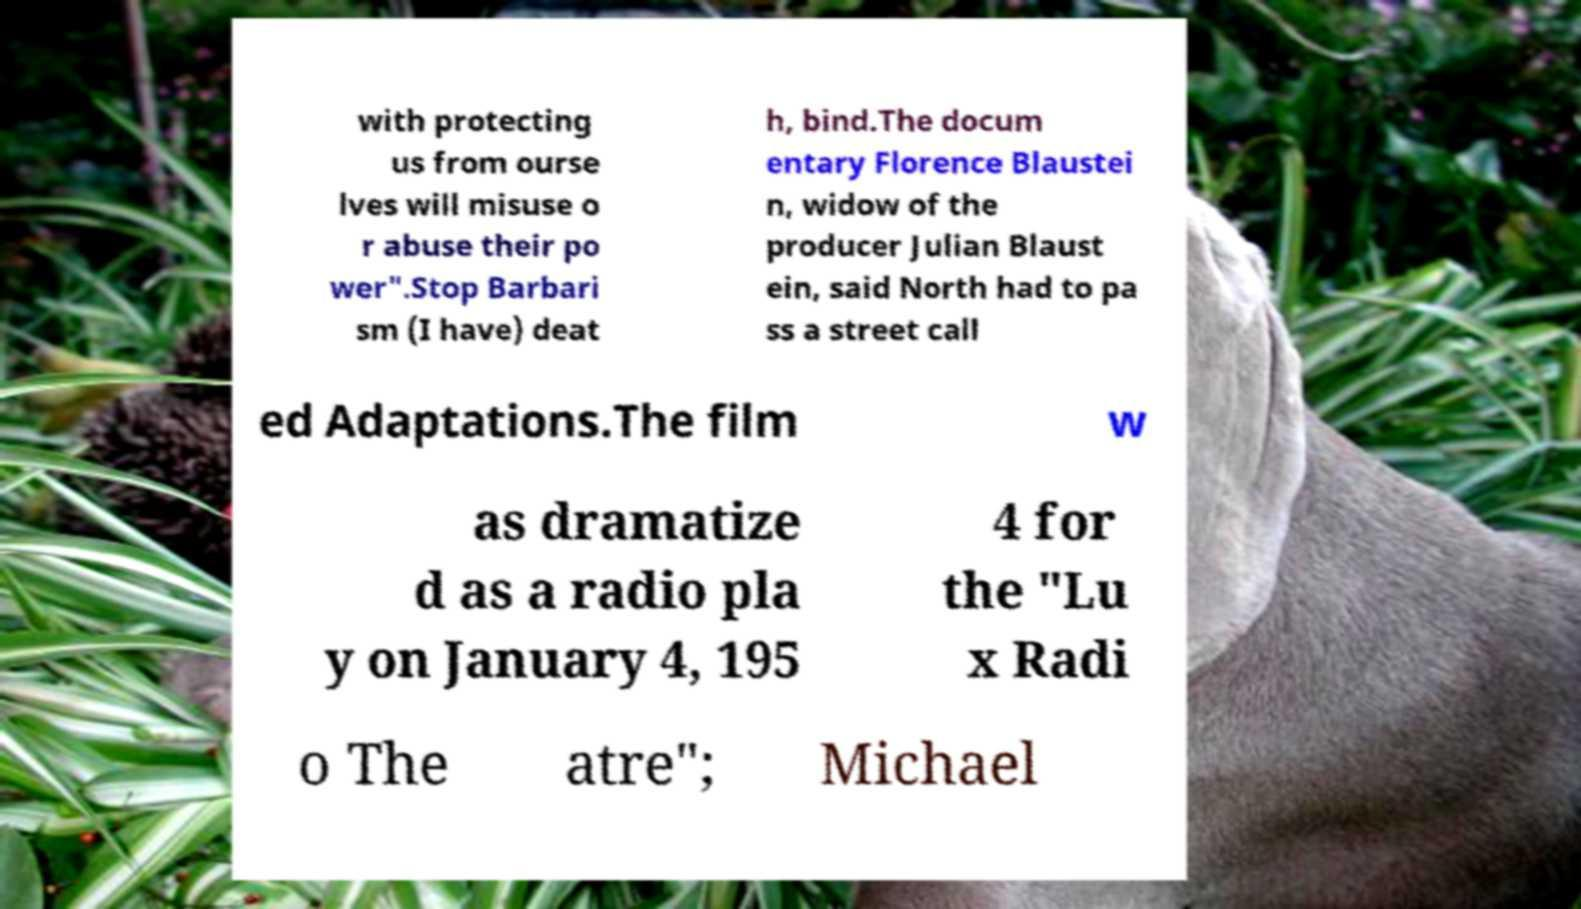Could you assist in decoding the text presented in this image and type it out clearly? with protecting us from ourse lves will misuse o r abuse their po wer".Stop Barbari sm (I have) deat h, bind.The docum entary Florence Blaustei n, widow of the producer Julian Blaust ein, said North had to pa ss a street call ed Adaptations.The film w as dramatize d as a radio pla y on January 4, 195 4 for the "Lu x Radi o The atre"; Michael 